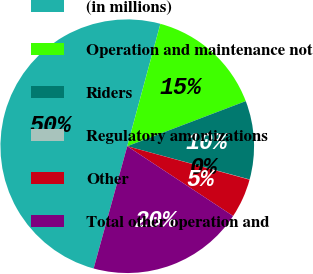Convert chart. <chart><loc_0><loc_0><loc_500><loc_500><pie_chart><fcel>(in millions)<fcel>Operation and maintenance not<fcel>Riders<fcel>Regulatory amortizations<fcel>Other<fcel>Total other operation and<nl><fcel>49.93%<fcel>15.0%<fcel>10.01%<fcel>0.03%<fcel>5.02%<fcel>19.99%<nl></chart> 